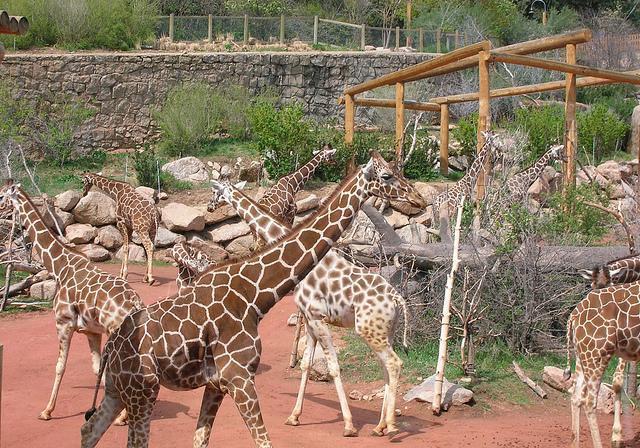How many giraffes are in the picture?
Give a very brief answer. 7. How many people are in this picture?
Give a very brief answer. 0. 